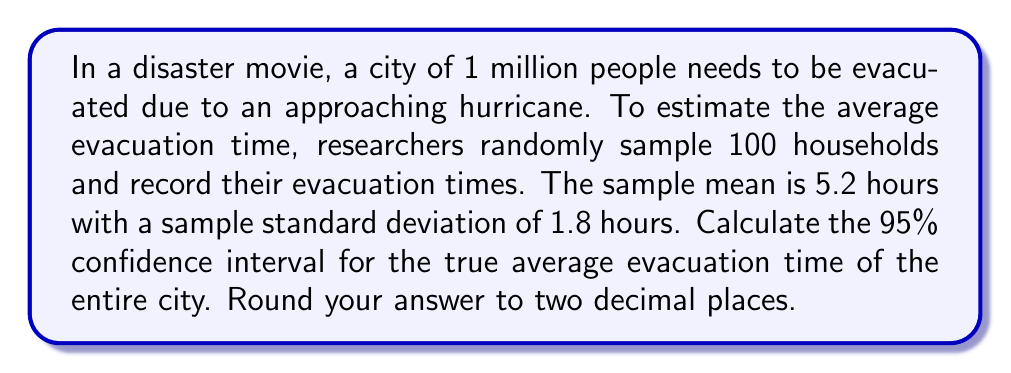Show me your answer to this math problem. To solve this problem, we'll use the formula for the confidence interval of a population mean when the population standard deviation is unknown:

$$ \bar{x} \pm t_{\frac{\alpha}{2}, n-1} \cdot \frac{s}{\sqrt{n}} $$

Where:
- $\bar{x}$ is the sample mean
- $t_{\frac{\alpha}{2}, n-1}$ is the t-value for a 95% confidence level with n-1 degrees of freedom
- $s$ is the sample standard deviation
- $n$ is the sample size

Given:
- Sample mean $\bar{x} = 5.2$ hours
- Sample standard deviation $s = 1.8$ hours
- Sample size $n = 100$
- Confidence level = 95%

Steps:
1. Find the t-value:
   For a 95% confidence level and 99 degrees of freedom (n-1 = 99), the t-value is approximately 1.984 (from t-distribution table).

2. Calculate the margin of error:
   $$ \text{Margin of Error} = t_{\frac{\alpha}{2}, n-1} \cdot \frac{s}{\sqrt{n}} = 1.984 \cdot \frac{1.8}{\sqrt{100}} = 0.3571 $$

3. Calculate the confidence interval:
   Lower bound: $5.2 - 0.3571 = 4.8429$
   Upper bound: $5.2 + 0.3571 = 5.5571$

4. Round to two decimal places:
   (4.84, 5.56)
Answer: The 95% confidence interval for the true average evacuation time is (4.84, 5.56) hours. 